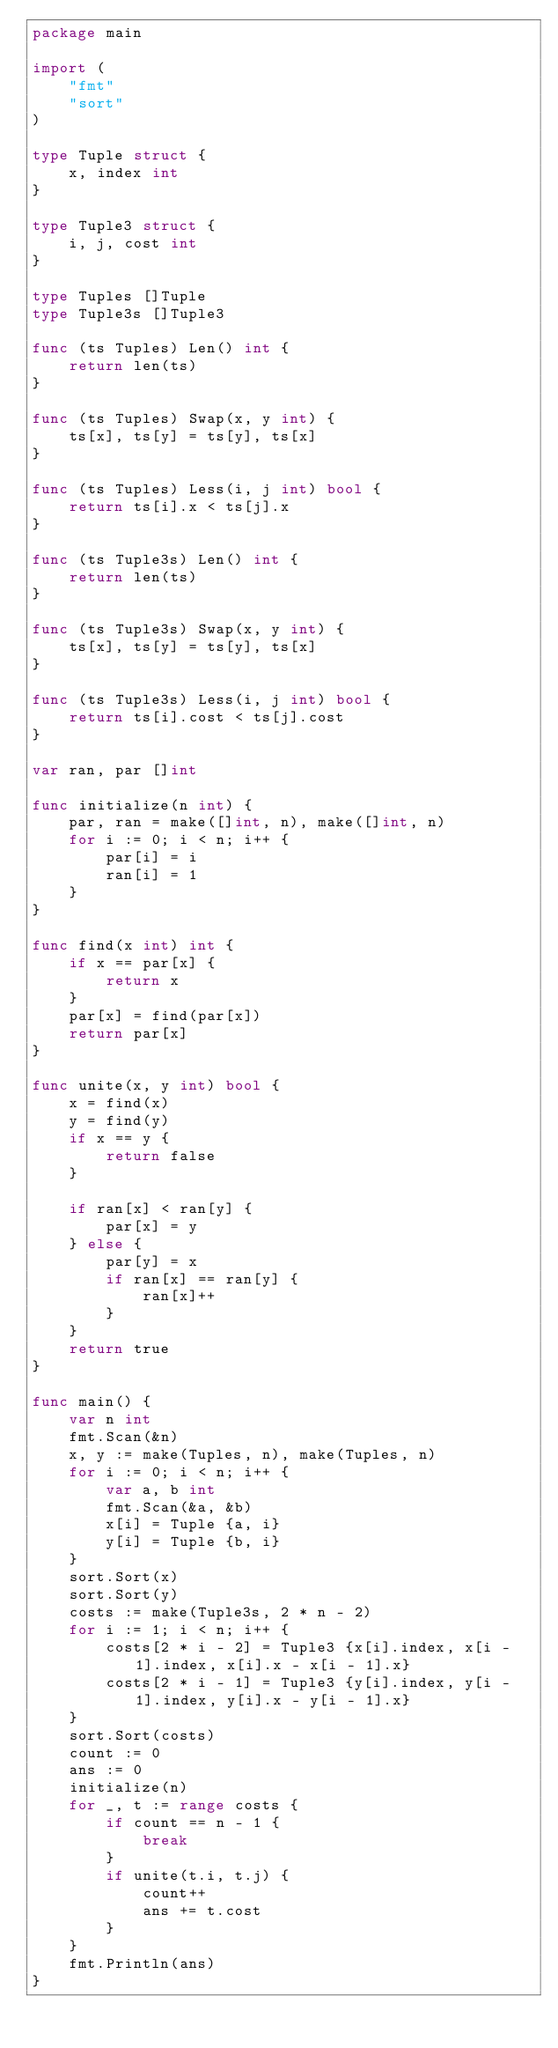<code> <loc_0><loc_0><loc_500><loc_500><_Go_>package main

import (
    "fmt"
    "sort"
)

type Tuple struct {
    x, index int
}

type Tuple3 struct {
    i, j, cost int
}

type Tuples []Tuple
type Tuple3s []Tuple3

func (ts Tuples) Len() int {
    return len(ts)
}

func (ts Tuples) Swap(x, y int) {
    ts[x], ts[y] = ts[y], ts[x]
}

func (ts Tuples) Less(i, j int) bool {
    return ts[i].x < ts[j].x
}

func (ts Tuple3s) Len() int {
    return len(ts)
}

func (ts Tuple3s) Swap(x, y int) {
    ts[x], ts[y] = ts[y], ts[x]
}

func (ts Tuple3s) Less(i, j int) bool {
    return ts[i].cost < ts[j].cost
}

var ran, par []int

func initialize(n int) {
    par, ran = make([]int, n), make([]int, n)
    for i := 0; i < n; i++ {
        par[i] = i
        ran[i] = 1
    }
}

func find(x int) int {
    if x == par[x] {
        return x
    }
    par[x] = find(par[x])
    return par[x]
}

func unite(x, y int) bool {
    x = find(x)
    y = find(y)
    if x == y {
        return false
    }

    if ran[x] < ran[y] {
        par[x] = y
    } else {
        par[y] = x
        if ran[x] == ran[y] {
            ran[x]++
        }
    }
    return true
}

func main() {
    var n int
    fmt.Scan(&n)
    x, y := make(Tuples, n), make(Tuples, n)
    for i := 0; i < n; i++ {
        var a, b int
        fmt.Scan(&a, &b)
        x[i] = Tuple {a, i}
        y[i] = Tuple {b, i}
    }
    sort.Sort(x)
    sort.Sort(y)
    costs := make(Tuple3s, 2 * n - 2)
    for i := 1; i < n; i++ {
        costs[2 * i - 2] = Tuple3 {x[i].index, x[i - 1].index, x[i].x - x[i - 1].x}
        costs[2 * i - 1] = Tuple3 {y[i].index, y[i - 1].index, y[i].x - y[i - 1].x}
    }
    sort.Sort(costs)
    count := 0
    ans := 0
    initialize(n)
    for _, t := range costs {
        if count == n - 1 {
            break
        }
        if unite(t.i, t.j) {
            count++
            ans += t.cost
        }
    }
    fmt.Println(ans)
}
</code> 